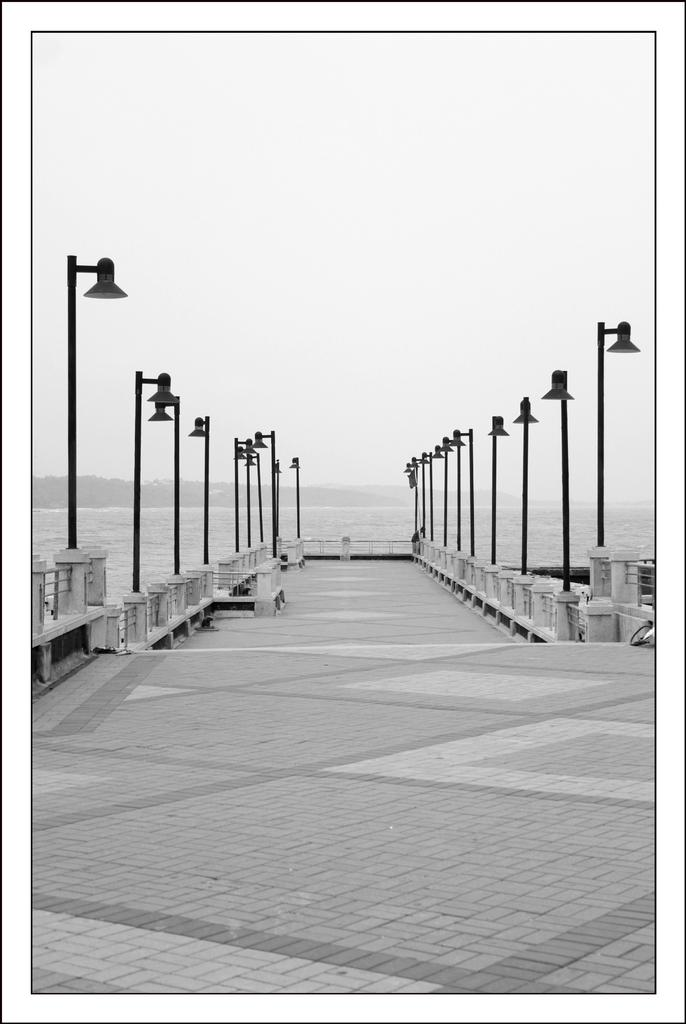What is the color scheme of the image? The image is black and white. What can be seen on both sides of the path in the image? There are street lights on both the right and left sides of the path. What is visible in the background of the image? There is water visible in the background, along with unspecified objects. Reasoning: Let's think step by identifying the main subjects and objects in the image based on the provided facts. We then formulate questions that focus on the location and characteristics of these subjects and objects, ensuring that each question can be answered definitively with the information given. We avoid yes/no questions and ensure that the language is simple and clear. Absurd Question/Answer: Can you hear the mother's voice in the image? There is no mention of a mother or any sound in the image, so it is not possible to hear a mother's voice. What type of crate is present in the image? There is no crate present in the image. How many crates are visible in the image? There are no crates present in the image. What type of hearing aid is the person wearing in the image? There is no person or hearing aid present in the image. 